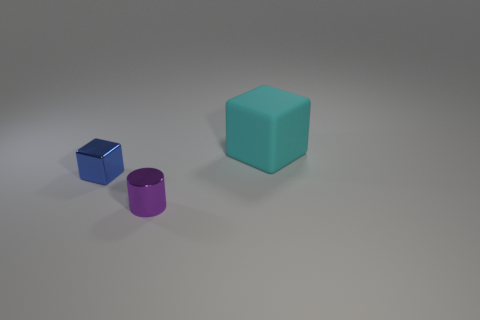Add 3 small red metal objects. How many objects exist? 6 Subtract 1 cubes. How many cubes are left? 1 Add 2 big cyan rubber blocks. How many big cyan rubber blocks are left? 3 Add 3 tiny objects. How many tiny objects exist? 5 Subtract all blue blocks. How many blocks are left? 1 Subtract 1 purple cylinders. How many objects are left? 2 Subtract all blocks. How many objects are left? 1 Subtract all red cubes. Subtract all gray balls. How many cubes are left? 2 Subtract all purple cubes. How many brown cylinders are left? 0 Subtract all blocks. Subtract all large cyan cubes. How many objects are left? 0 